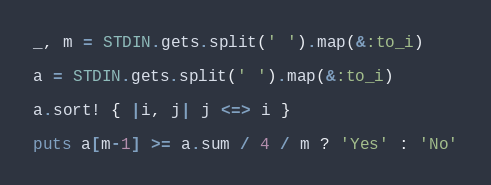Convert code to text. <code><loc_0><loc_0><loc_500><loc_500><_Ruby_>_, m = STDIN.gets.split(' ').map(&:to_i)

a = STDIN.gets.split(' ').map(&:to_i)

a.sort! { |i, j| j <=> i }

puts a[m-1] >= a.sum / 4 / m ? 'Yes' : 'No'
</code> 